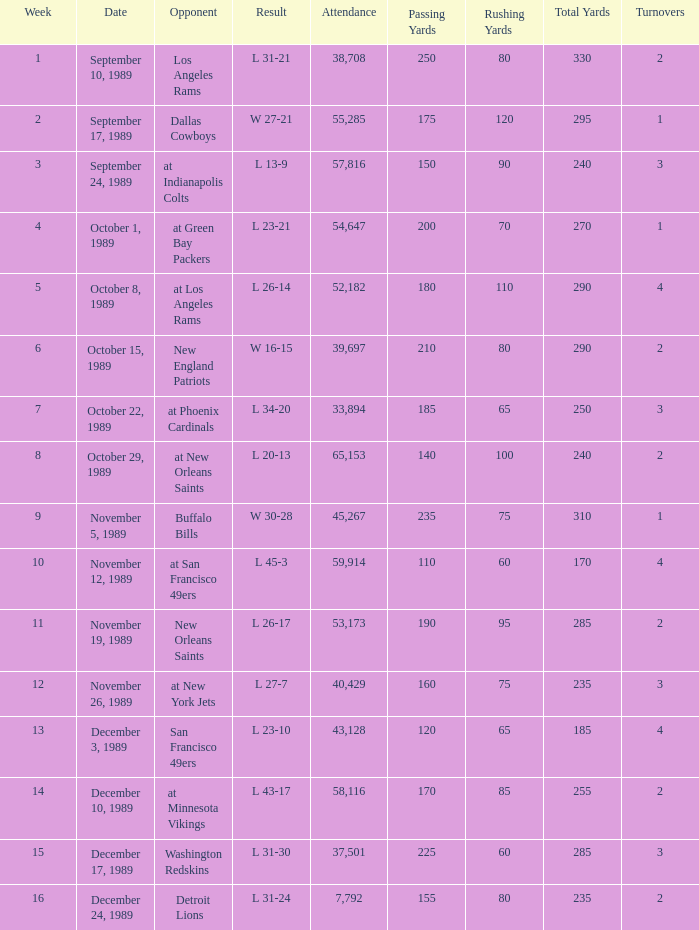On September 10, 1989 how many people attended the game? 38708.0. 